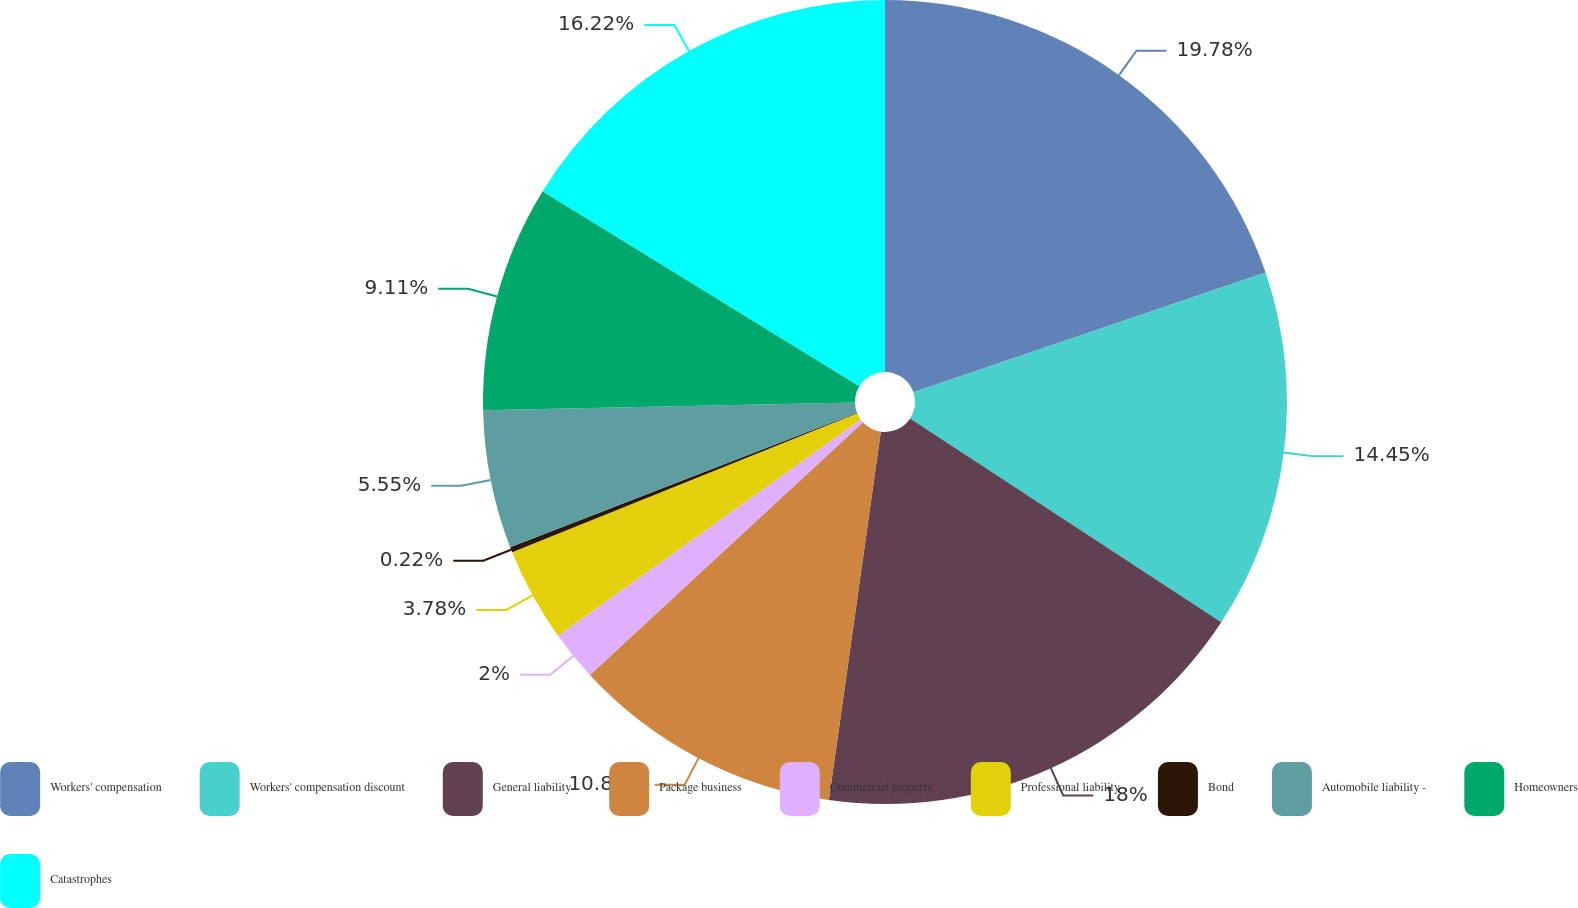<chart> <loc_0><loc_0><loc_500><loc_500><pie_chart><fcel>Workers' compensation<fcel>Workers' compensation discount<fcel>General liability<fcel>Package business<fcel>Commercial property<fcel>Professional liability<fcel>Bond<fcel>Automobile liability -<fcel>Homeowners<fcel>Catastrophes<nl><fcel>19.78%<fcel>14.45%<fcel>18.0%<fcel>10.89%<fcel>2.0%<fcel>3.78%<fcel>0.22%<fcel>5.55%<fcel>9.11%<fcel>16.22%<nl></chart> 